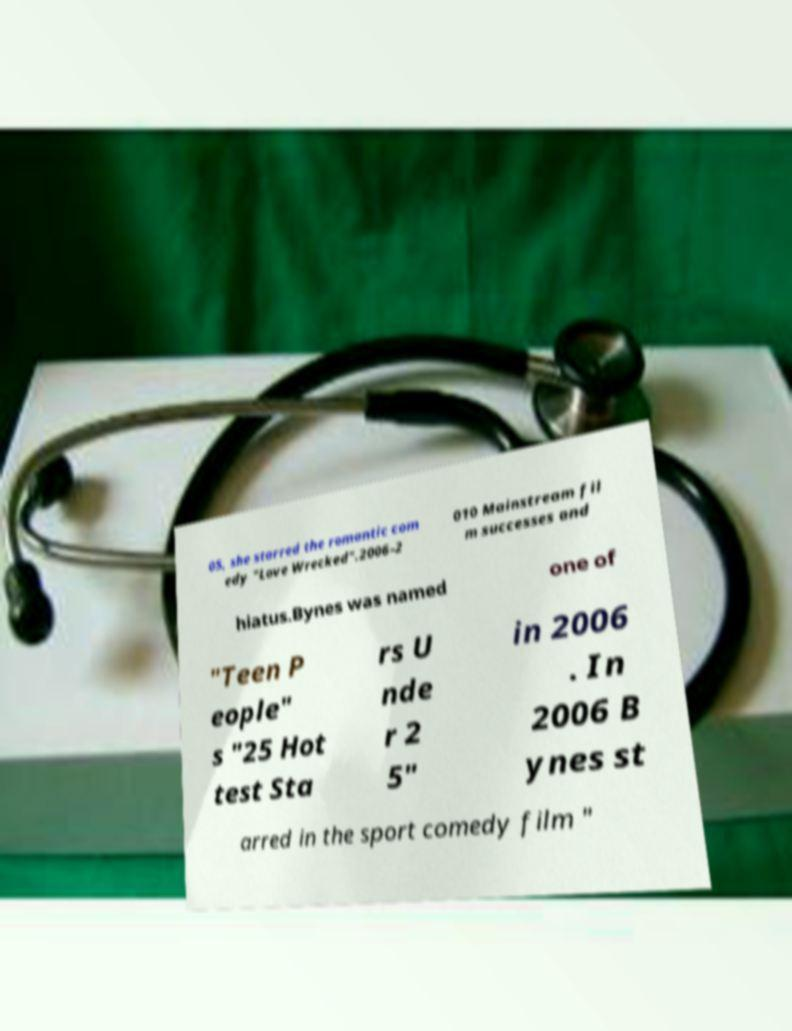Can you read and provide the text displayed in the image?This photo seems to have some interesting text. Can you extract and type it out for me? 05, she starred the romantic com edy "Love Wrecked".2006–2 010 Mainstream fil m successes and hiatus.Bynes was named one of "Teen P eople" s "25 Hot test Sta rs U nde r 2 5" in 2006 . In 2006 B ynes st arred in the sport comedy film " 